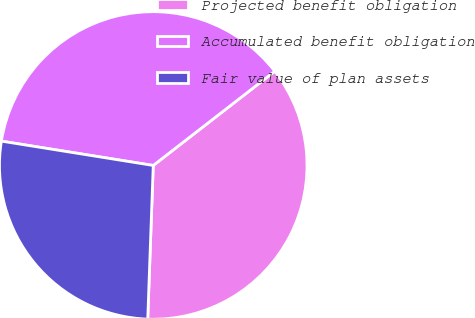Convert chart to OTSL. <chart><loc_0><loc_0><loc_500><loc_500><pie_chart><fcel>Projected benefit obligation<fcel>Accumulated benefit obligation<fcel>Fair value of plan assets<nl><fcel>36.07%<fcel>36.98%<fcel>26.96%<nl></chart> 